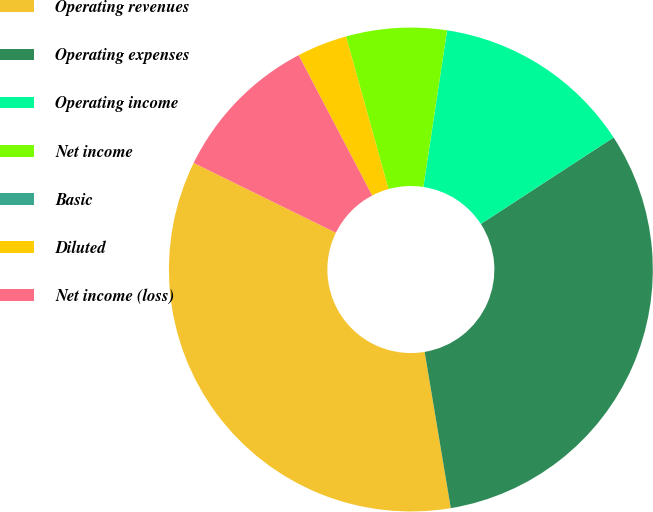<chart> <loc_0><loc_0><loc_500><loc_500><pie_chart><fcel>Operating revenues<fcel>Operating expenses<fcel>Operating income<fcel>Net income<fcel>Basic<fcel>Diluted<fcel>Net income (loss)<nl><fcel>34.9%<fcel>31.55%<fcel>13.42%<fcel>6.71%<fcel>0.0%<fcel>3.36%<fcel>10.06%<nl></chart> 